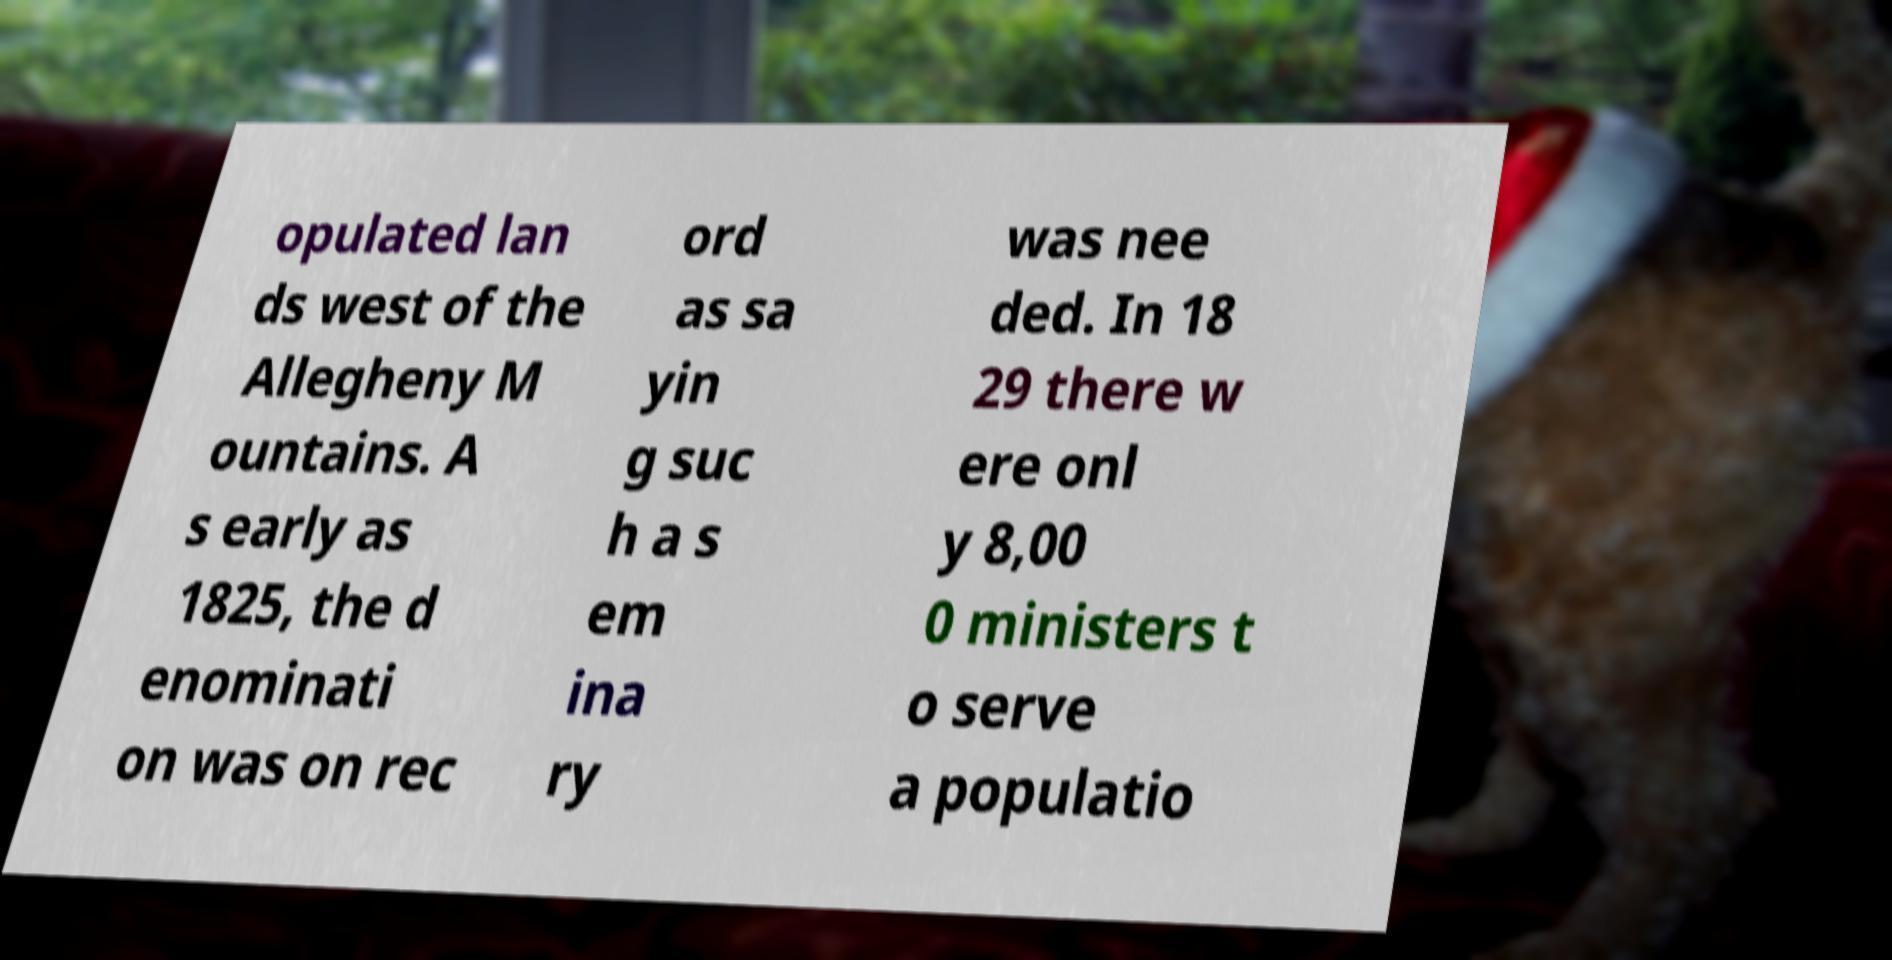There's text embedded in this image that I need extracted. Can you transcribe it verbatim? opulated lan ds west of the Allegheny M ountains. A s early as 1825, the d enominati on was on rec ord as sa yin g suc h a s em ina ry was nee ded. In 18 29 there w ere onl y 8,00 0 ministers t o serve a populatio 